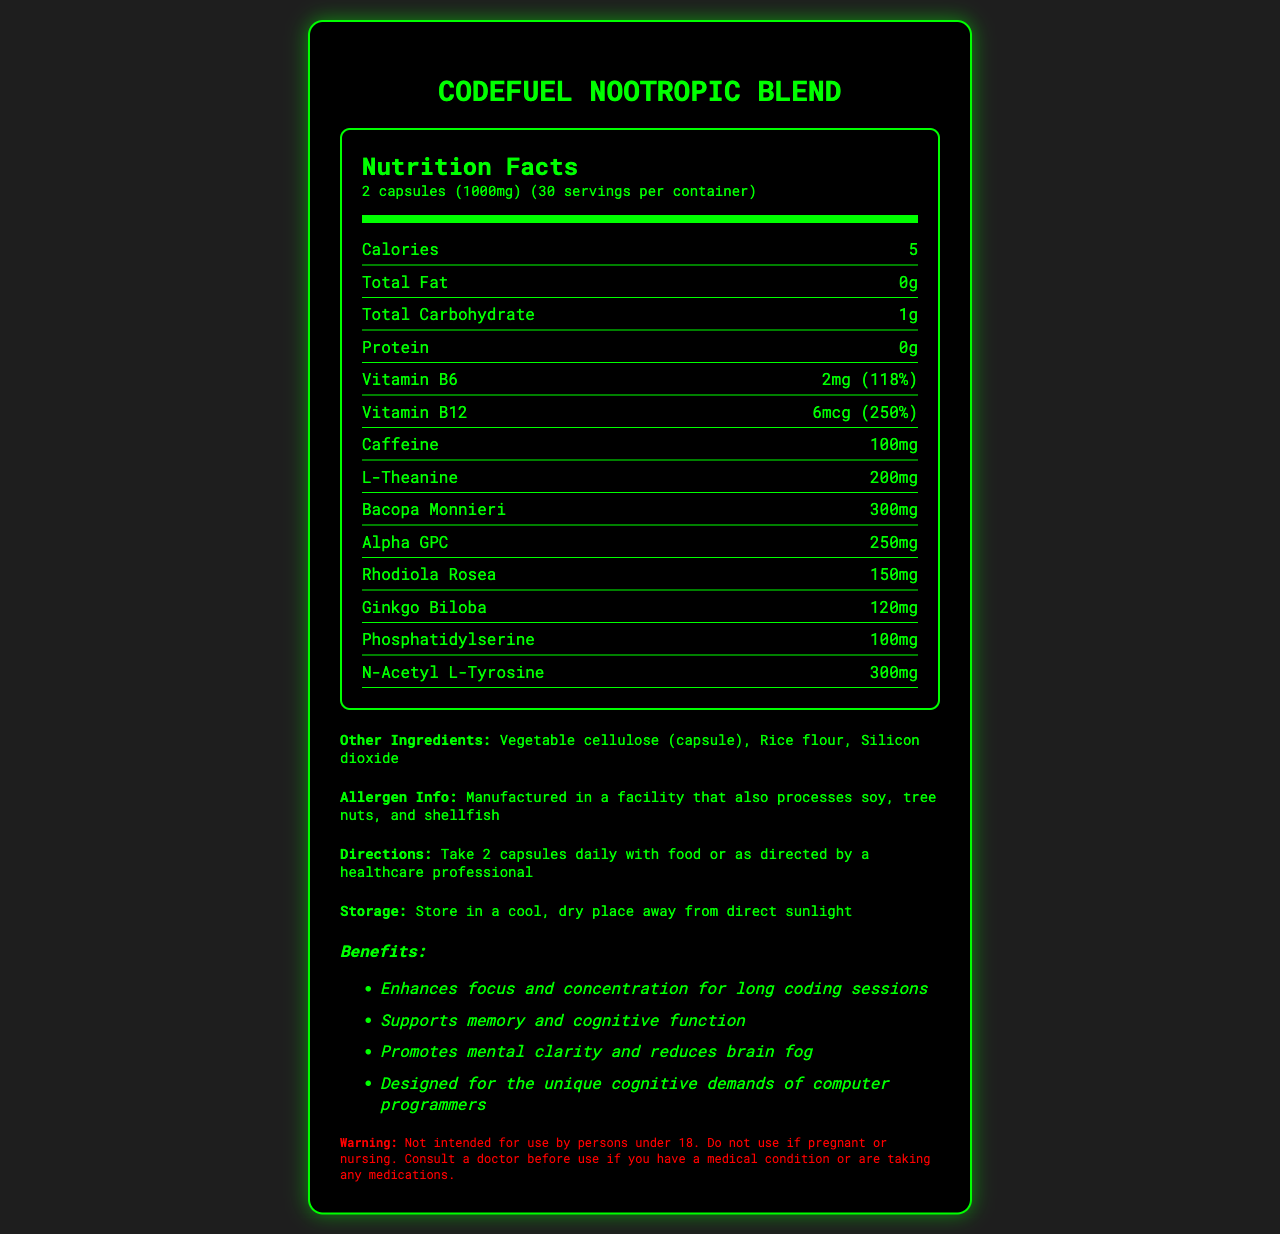what is the serving size for CodeFuel Nootropic Blend? The serving size is listed at the top of the Nutrition Facts section as "2 capsules (1000mg)."
Answer: 2 capsules (1000mg) how many calories are in a single serving? The nutrition label mentions "Calories" and lists 5 as the value.
Answer: 5 what is the total carbohydrate content per serving? The total carbohydrate amount is shown as 1g in the nutrition label.
Answer: 1g does CodeFuel Nootropic Blend contain any protein? The nutrition label lists "Protein" as 0g, indicating no protein content.
Answer: No what is the percentage of daily value for vitamin B6? The Nutrition Facts section states that vitamin B6 is 118% of the daily value.
Answer: 118% how many servings are in one container? The serving per container is specified as 30 in the Nutrition Facts section.
Answer: 30 what is the caffeine content per serving? A. 50mg B. 100mg C. 150mg The nutrition label shows the caffeine content as 100mg, so the correct option is B.
Answer: B which ingredient is present in the greatest quantity? A. Bacopa Monnieri B. Alpha GPC C. L-Theanine Bacopa Monnieri is listed at 300mg, which is the highest among the options.
Answer: A is the CodeFuel Nootropic Blend safe for pregnant women? The warning section specifically states that it should not be used if pregnant or nursing.
Answer: No what are the directions for using CodeFuel Nootropic Blend? The directions clearly mention to take 2 capsules daily with food or as directed by a healthcare professional.
Answer: Take 2 capsules daily with food or as directed by a healthcare professional summarize the main benefits of CodeFuel Nootropic Blend according to the marketing claims. The marketing claims section lists these key benefits of the supplement.
Answer: Enhances focus and concentration, supports memory and cognitive function, promotes mental clarity, reduces brain fog, designed for programmers what are the active ingredients in CodeFuel Nootropic Blend? The active ingredients are listed as part of the nutrition facts label in the document.
Answer: Vitamin B6, Vitamin B12, Caffeine, L-Theanine, Bacopa Monnieri, Alpha GPC, Rhodiola Rosea, Ginkgo Biloba, Phosphatidylserine, N-Acetyl L-Tyrosine does CodeFuel Nootropic Blend contain any allergens? The allergen info section specifies that the product is manufactured in a facility processing these allergens, but it's unclear if the product itself contains them.
Answer: Manufactured in a facility that processes soy, tree nuts, and shellfish where should CodeFuel Nootropic Blend be stored? The storage instructions specify to store the supplement in a cool, dry place away from direct sunlight.
Answer: Store in a cool, dry place away from direct sunlight how should someone decide whether to take CodeFuel Nootropic Blend? The warning advises consulting a doctor if one has a medical condition or is taking any medications.
Answer: Consult a doctor before use if you have a medical condition or are taking any medications what is the price of CodeFuel Nootropic Blend? The document does not mention the price of the supplement.
Answer: Not enough information 